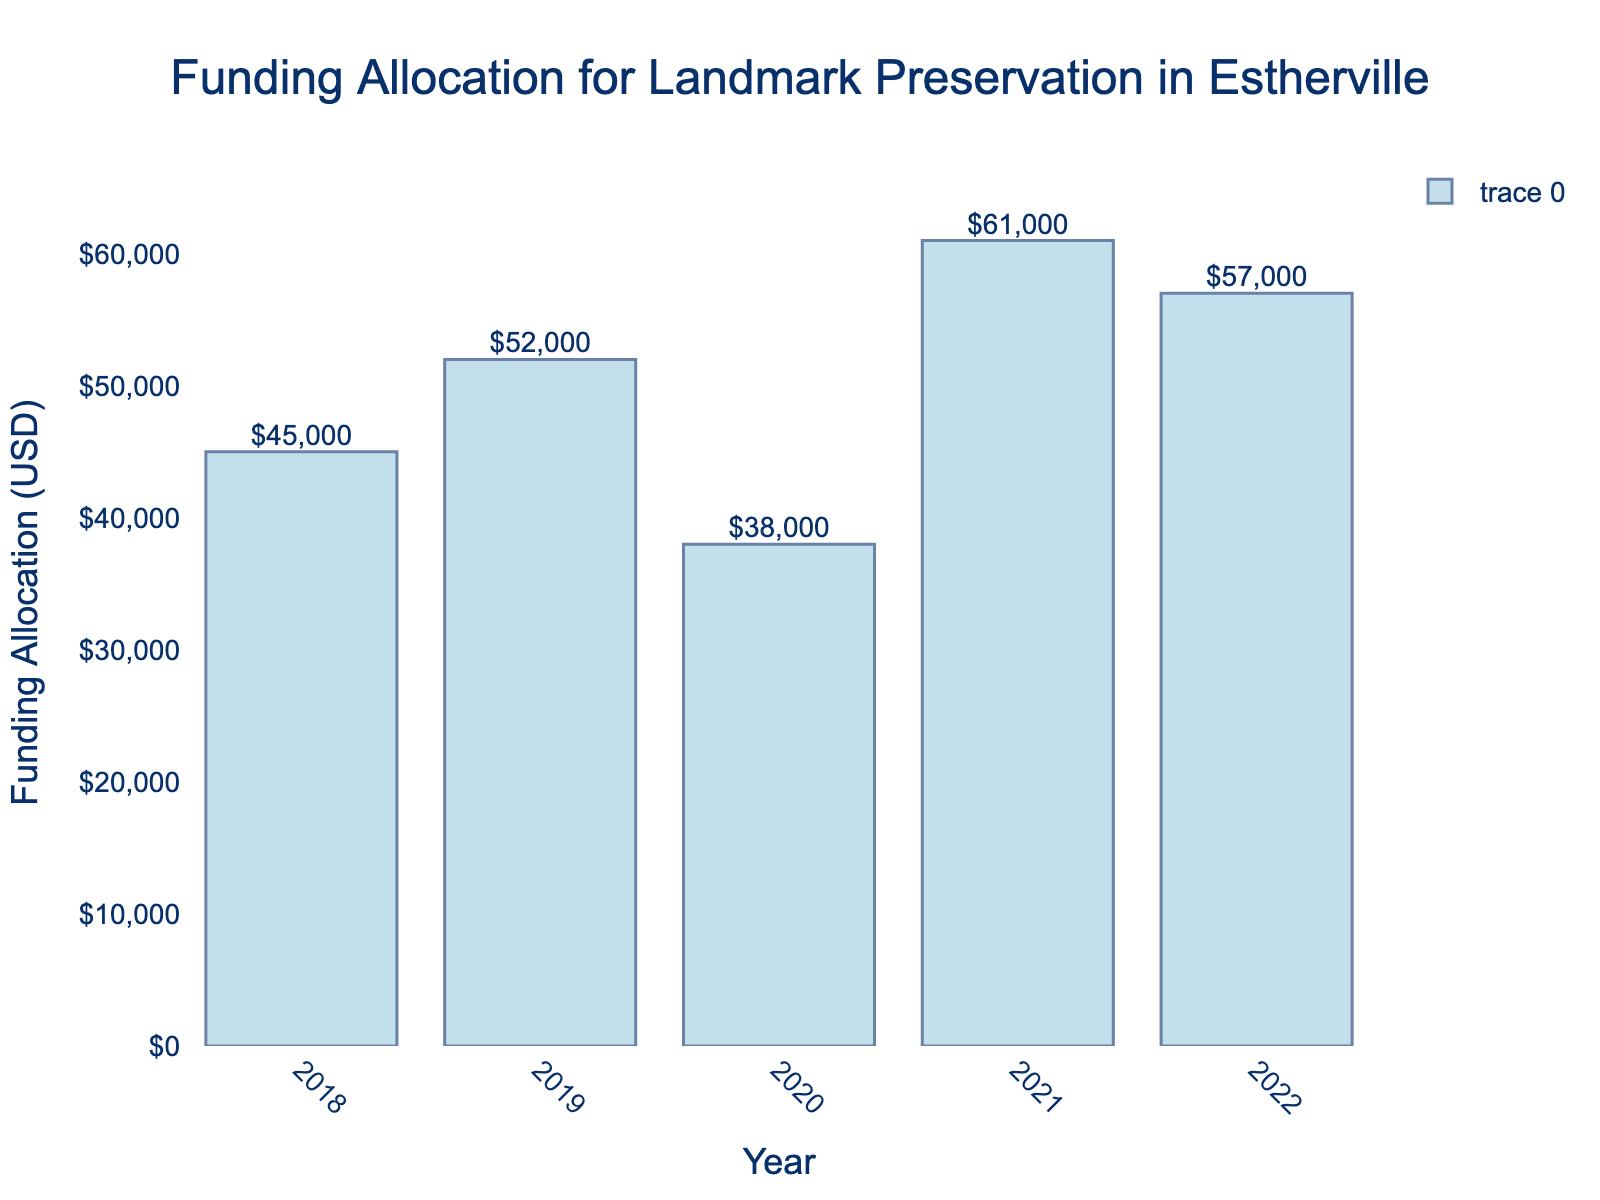Which year received the highest funding allocation for landmark preservation? The bar for 2021 is the tallest, indicating the highest funding allocation.
Answer: 2021 Which year received the lowest funding allocation? The year 2020 has the shortest bar, indicating the lowest funding allocation.
Answer: 2020 What is the total funding allocation over the 5 years? Sum the values: $45,000 (2018) + $52,000 (2019) + $38,000 (2020) + $61,000 (2021) + $57,000 (2022) = $253,000
Answer: $253,000 By how much did the funding allocation increase from 2018 to 2019? Subtract the 2018 funding from the 2019 funding: $52,000 - $45,000 = $7,000
Answer: $7,000 What is the average funding allocation per year over the 5 years? Divide the total funding allocation by the number of years: $253,000 / 5 = $50,600
Answer: $50,600 How much more funding was allocated in 2021 compared to 2020? Subtract the 2020 funding from the 2021 funding: $61,000 - $38,000 = $23,000
Answer: $23,000 Which year saw a decrease in funding allocation compared to the previous year? Compare each year to the previous one: 2020 had less funding than 2019 ($38,000 < $52,000).
Answer: 2020 What is the difference in funding allocation between the year with the highest funding and the year with the lowest funding? Subtract the lowest amount (2020) from the highest (2021): $61,000 - $38,000 = $23,000
Answer: $23,000 Which years received more funding than the average funding allocation? The average funding allocation is $50,600. The years 2019 ($52,000), 2021 ($61,000), and 2022 ($57,000) received more than the average.
Answer: 2019, 2021, 2022 